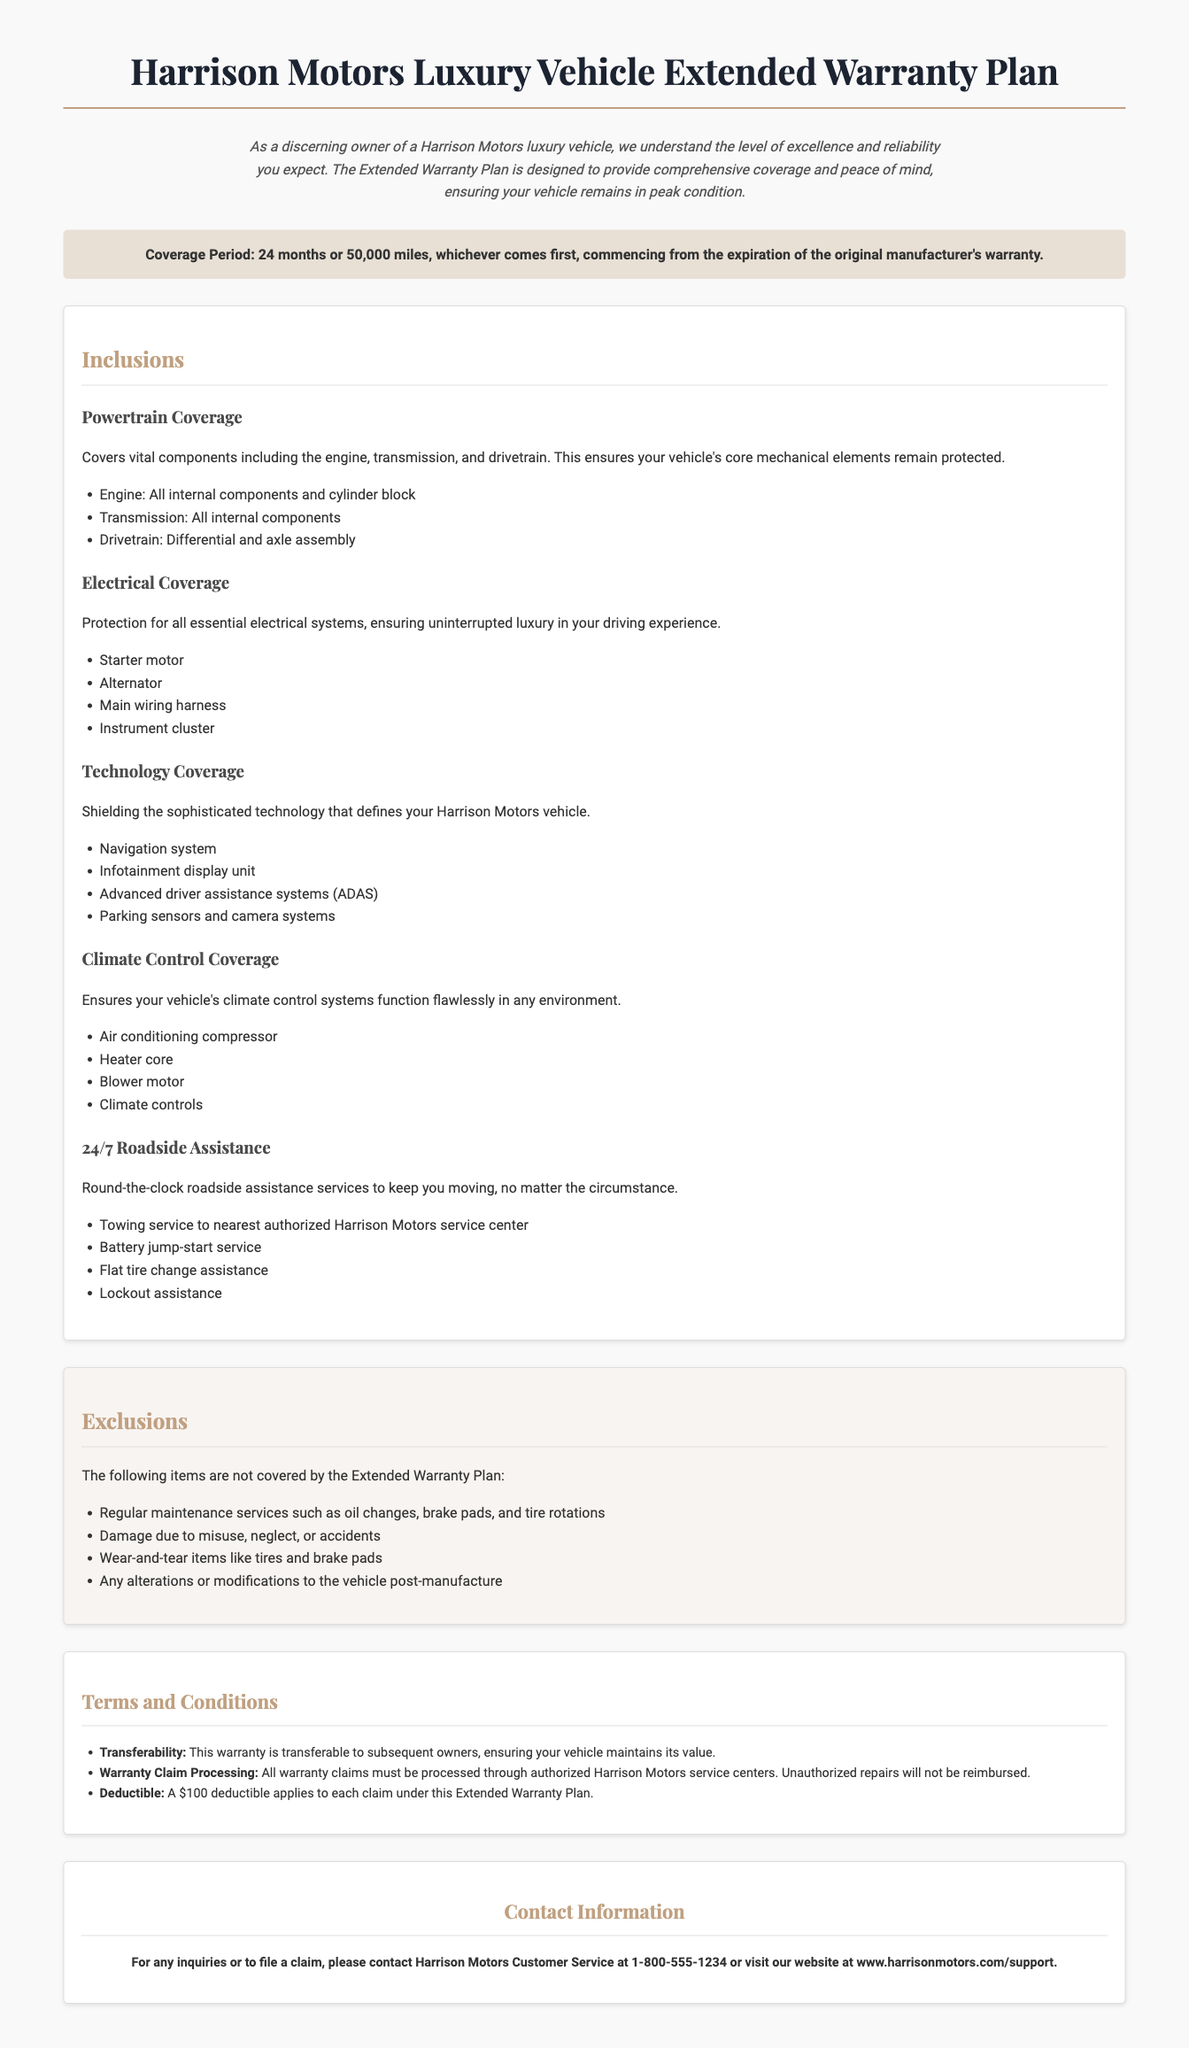What is the coverage period of the warranty? The coverage period is specified as 24 months or 50,000 miles, whichever comes first.
Answer: 24 months or 50,000 miles What is included in Powertrain Coverage? Powertrain Coverage includes vital components like the engine, transmission, and drivetrain.
Answer: Engine, transmission, and drivetrain What is the deductible for claims? The document states that a $100 deductible applies to each claim under this Extended Warranty Plan.
Answer: $100 What type of vehicle does this warranty apply to? The warranty is specifically designed for owners of Harrison Motors luxury vehicles.
Answer: Harrison Motors luxury vehicles Are regular maintenance services covered? Regular maintenance services are explicitly listed as exclusions in the document.
Answer: No Is the warranty transferable to subsequent owners? The document confirms that the warranty is transferable, which adds value to the vehicle.
Answer: Yes What type of assistance does the 24/7 roadside coverage provide? The coverage provides various forms of assistance including towing, battery jump-start, flat tire change, and lockout assistance.
Answer: Towing, battery jump-start, flat tire change, lockout assistance Which items are excluded in the warranty? Exclusions include wear-and-tear items like tires and brake pads.
Answer: Wear-and-tear items like tires and brake pads 